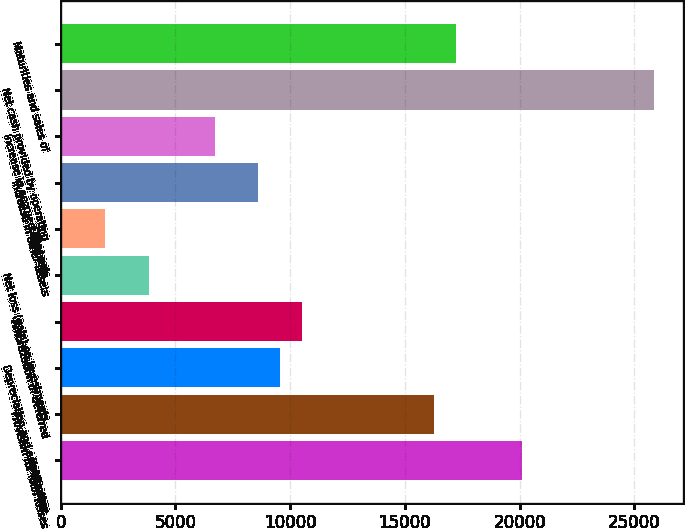<chart> <loc_0><loc_0><loc_500><loc_500><bar_chart><fcel>Net income<fcel>Provision for loan losses<fcel>Depreciation and amortization<fcel>Amortization of deferred<fcel>Net loss (gain) on investments<fcel>Other net<fcel>Increase in other assets<fcel>Increase in accrued expenses<fcel>Net cash provided by operating<fcel>Maturities and sales of<nl><fcel>20095.7<fcel>16268.9<fcel>9572<fcel>10528.7<fcel>3831.8<fcel>1918.4<fcel>8615.3<fcel>6701.9<fcel>25835.9<fcel>17225.6<nl></chart> 